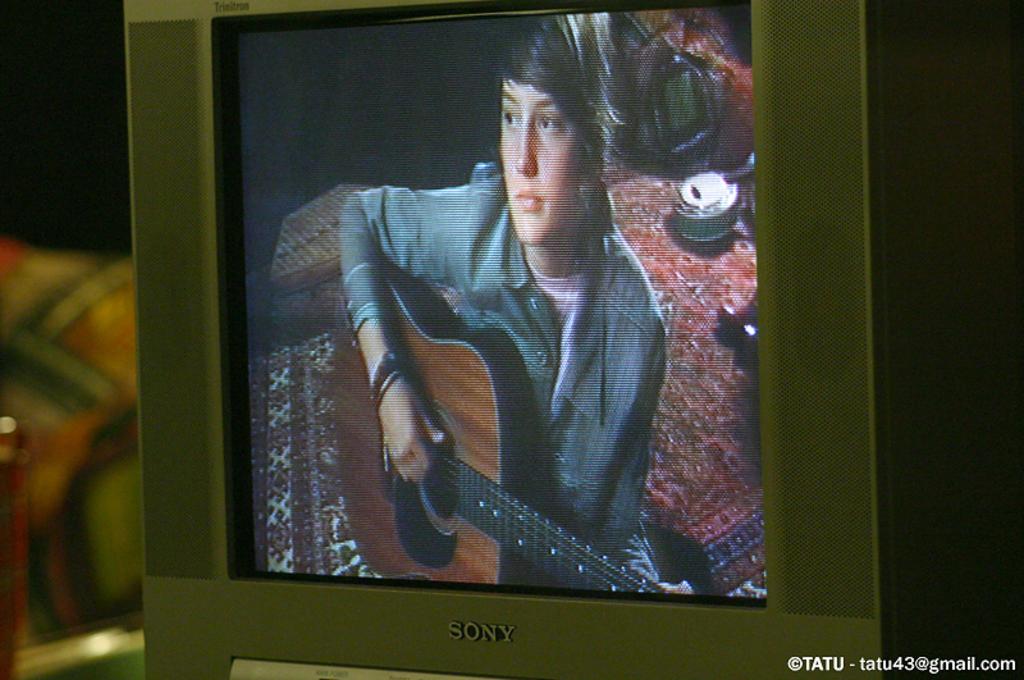Who does the copyright belong to?
Provide a short and direct response. Tatu. Name the t.v. brand?
Your response must be concise. Sony. 